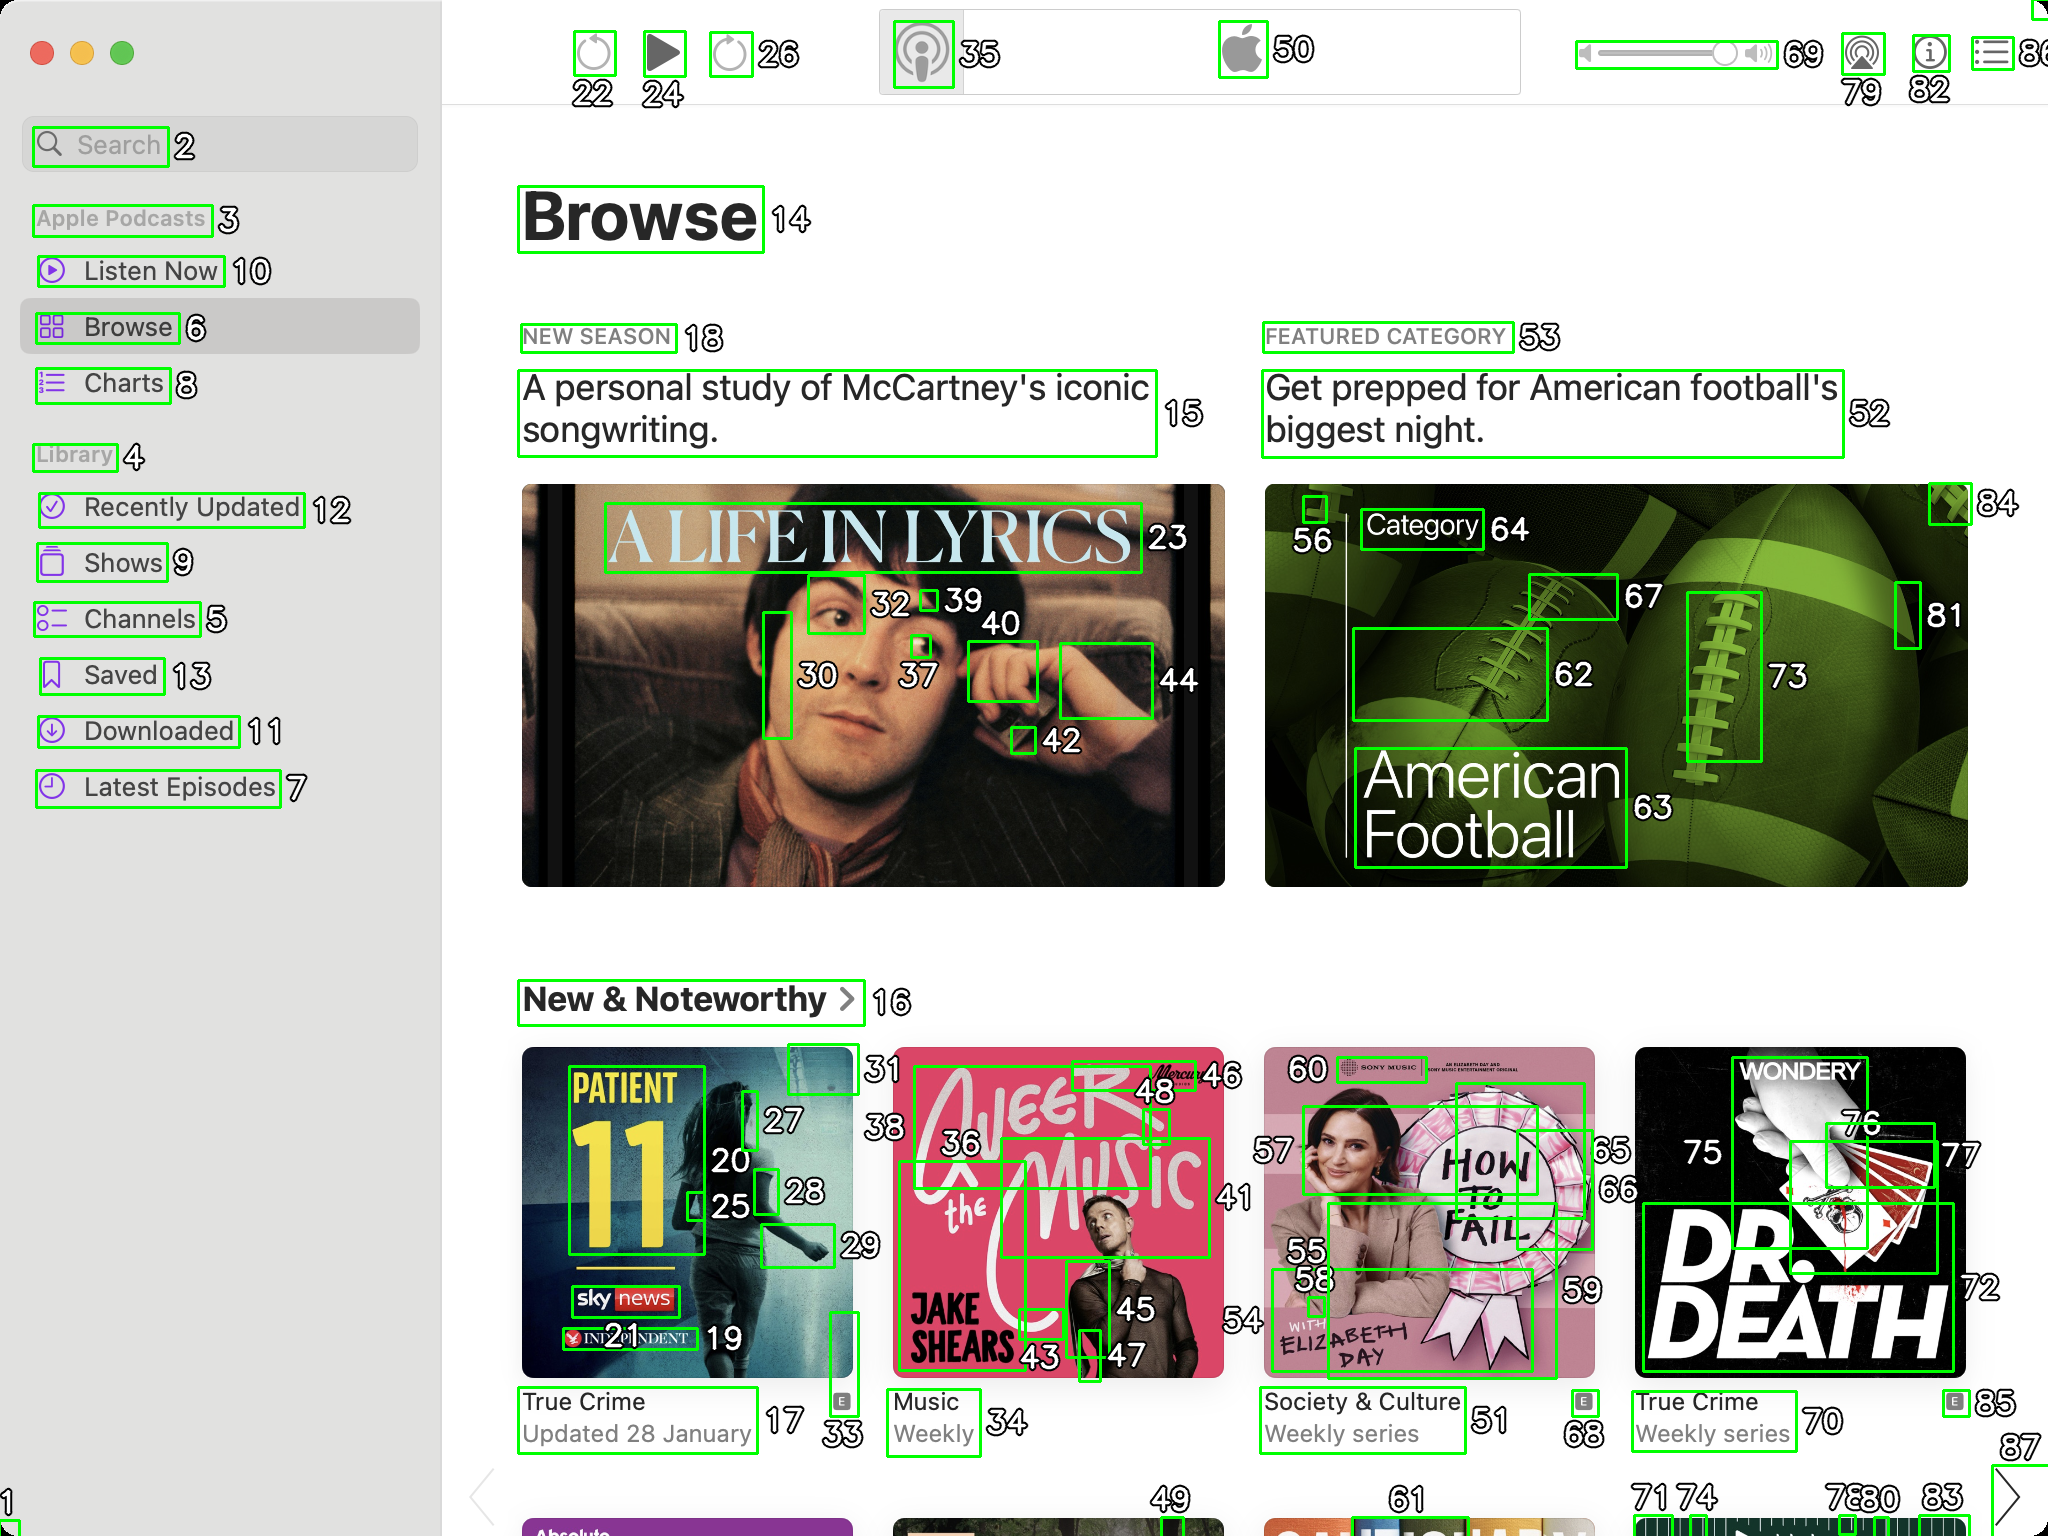You are an AI designed for image processing and segmentation analysis, particularly skilled in merging segmented regions of an image to improve accuracy and readability.

**Task Description:**
Your task is to address a user's concern with a UI screenshot of the Apple Podcasts application on MacOS. The screenshot contains multiple green boxes, each representing a UI element, with a unique white number outlined in black ranging from 1 to 88. Due to segmentation issues, some boxes that belong to the same UI element are divided unnaturally.

**Objective:**
Merge these segmented areas that correspond to a single UI element to create a coherent representation. The final output should be in JSON format, where each key-value pair represents the merged areas.

**Example JSON Output:**
If boxes with numbers 1, 2, and 3 should belong to the same UI element, the JSON output should be:

```json
{
    "UI Element 1": [1, 2, 3]
}```

**Instructions:**

- **Identify Segmented Regions:** Analyze the screenshot to identify which green boxes belong to the same UI element.
- **Merge Regions:** Group the numbers of these boxes together to represent a single UI element.
- **Output Format:** Produce the output in JSON format, with each key representing a UI element and each value being a list of the numbers of the merged boxes.

**Primary Objective:**
Ensure the accuracy of the merged regions based on the user's supplied image information, maintaining the integrity and structure of the UI elements in the Apple Podcasts application on MacOS. Based on the provided screenshot, I've identified which green boxes belong to the same UI elements and merged them appropriately. Here is the JSON output representing the merged areas:

```json
{
    "UI Element 1": [2],
    "UI Element 2": [3],
    "UI Element 3": [4],
    "UI Element 4": [5],
    "UI Element 5": [6],
    "UI Element 6": [7],
    "UI Element 7": [8],
    "UI Element 8": [9],
    "UI Element 9": [10],
    "UI Element 10": [11],
    "UI Element 11": [12],
    "UI Element 12": [13],
    "UI Element 13": [14],
    "UI Element 14": [15],
    "UI Element 15": [16],
    "UI Element 16": [17, 18, 19],
    "UI Element 17": [20, 21, 22],
    "UI Element 18": [23, 24, 25],
    "UI Element 19": [26, 27, 28],
    "UI Element 20": [29, 30, 31],
    "UI Element 21": [32, 33, 34],
    "UI Element 22": [35, 36, 37],
    "UI Element 23": [38, 39, 40],
    "UI Element 24": [41, 42, 43],
    "UI Element 25": [44, 45, 46],
    "UI Element 26": [47, 48, 49],
    "UI Element 27": [50],
    "UI Element 28": [51],
    "UI Element 29": [52],
    "UI Element 30": [53],
    "UI Element 31": [54, 55, 56],
    "UI Element 32": [57, 58, 59],
    "UI Element 33": [60, 61, 62],
    "UI Element 34": [63, 64, 65],
    "UI Element 35": [66, 67, 68],
    "UI Element 36": [69],
    "UI Element 37": [70],
    "UI Element 38": [71, 72, 73],
    "UI Element 39": [74, 75, 76],
    "UI Element 40": [77, 78, 79],
    "UI Element 41": [80],
    "UI Element 42": [81],
    "UI Element 43": [82],
    "UI Element 44": [83],
    "UI Element 45": [84],
    "UI Element 46": [85, 86, 87, 88]
}
```

This JSON output reflects the merged regions from the provided screenshot, where each key represents a UI element and the values are lists of the numbers of the merged boxes. 